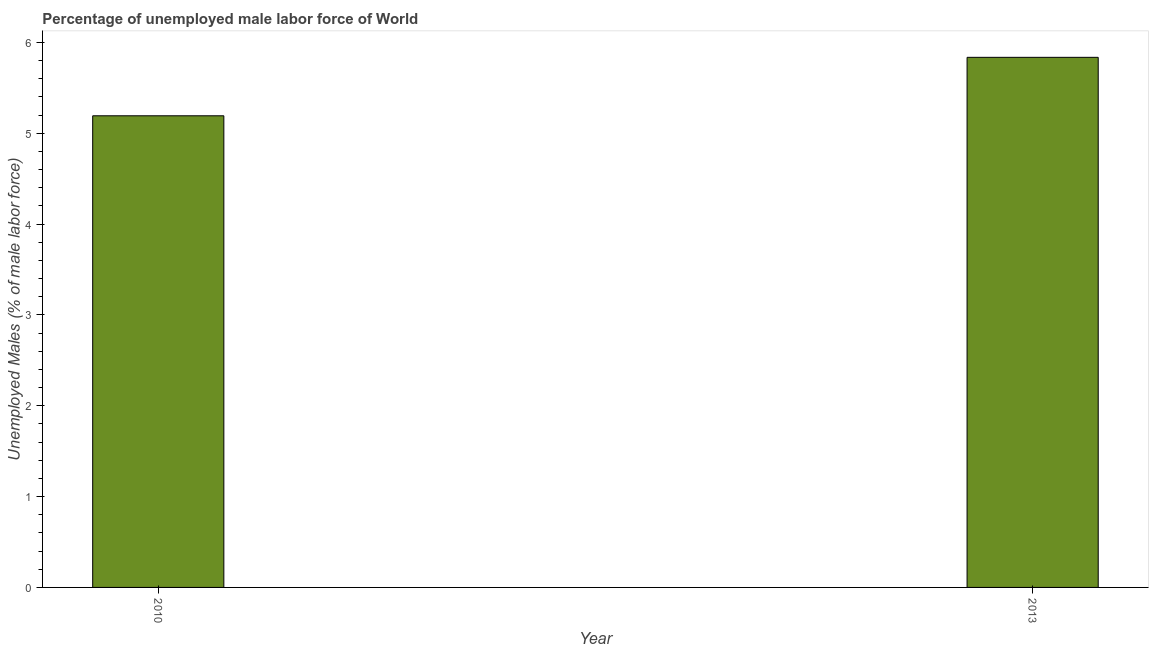What is the title of the graph?
Provide a short and direct response. Percentage of unemployed male labor force of World. What is the label or title of the X-axis?
Offer a very short reply. Year. What is the label or title of the Y-axis?
Offer a very short reply. Unemployed Males (% of male labor force). What is the total unemployed male labour force in 2010?
Provide a succinct answer. 5.19. Across all years, what is the maximum total unemployed male labour force?
Give a very brief answer. 5.84. Across all years, what is the minimum total unemployed male labour force?
Your answer should be very brief. 5.19. What is the sum of the total unemployed male labour force?
Offer a very short reply. 11.03. What is the difference between the total unemployed male labour force in 2010 and 2013?
Give a very brief answer. -0.64. What is the average total unemployed male labour force per year?
Make the answer very short. 5.51. What is the median total unemployed male labour force?
Keep it short and to the point. 5.51. Do a majority of the years between 2010 and 2013 (inclusive) have total unemployed male labour force greater than 0.8 %?
Your answer should be compact. Yes. What is the ratio of the total unemployed male labour force in 2010 to that in 2013?
Ensure brevity in your answer.  0.89. Is the total unemployed male labour force in 2010 less than that in 2013?
Your answer should be compact. Yes. Are all the bars in the graph horizontal?
Provide a succinct answer. No. What is the difference between two consecutive major ticks on the Y-axis?
Provide a short and direct response. 1. Are the values on the major ticks of Y-axis written in scientific E-notation?
Ensure brevity in your answer.  No. What is the Unemployed Males (% of male labor force) in 2010?
Give a very brief answer. 5.19. What is the Unemployed Males (% of male labor force) of 2013?
Provide a short and direct response. 5.84. What is the difference between the Unemployed Males (% of male labor force) in 2010 and 2013?
Offer a terse response. -0.64. What is the ratio of the Unemployed Males (% of male labor force) in 2010 to that in 2013?
Keep it short and to the point. 0.89. 